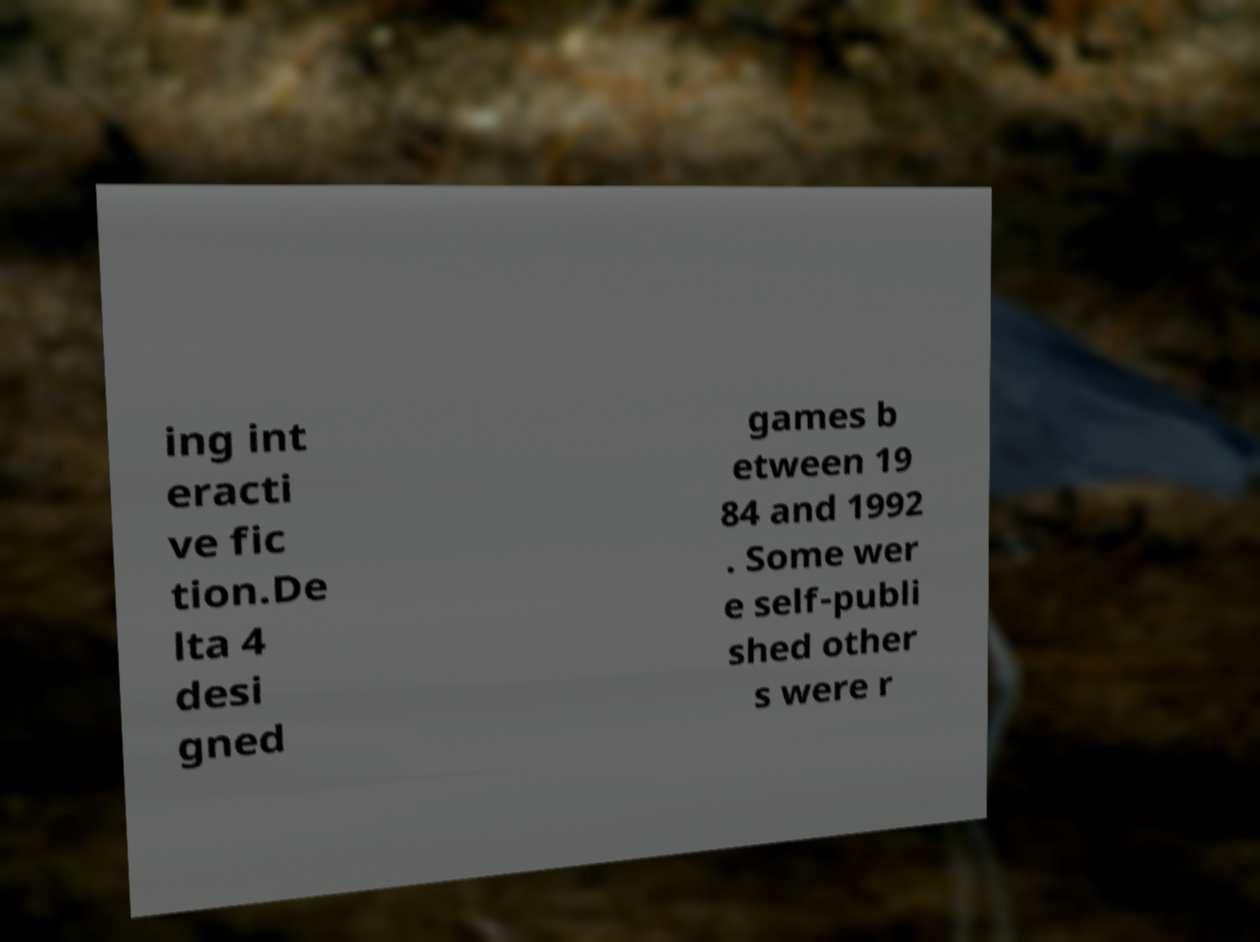For documentation purposes, I need the text within this image transcribed. Could you provide that? ing int eracti ve fic tion.De lta 4 desi gned games b etween 19 84 and 1992 . Some wer e self-publi shed other s were r 